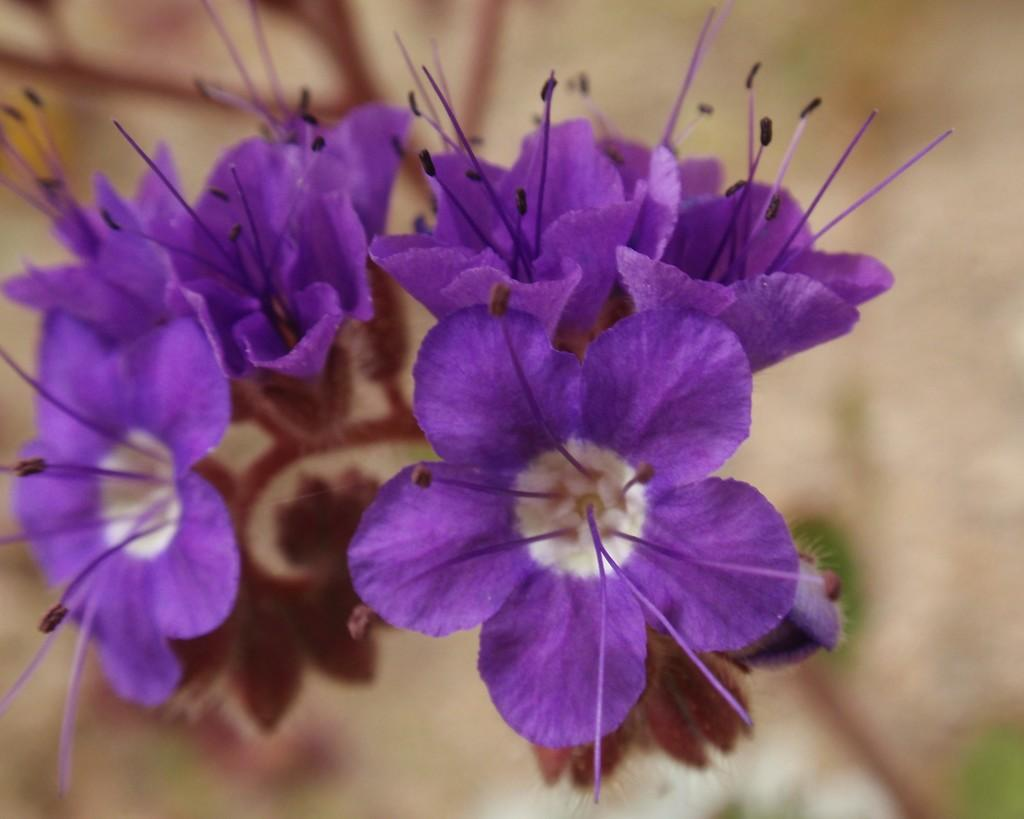What type of living organisms can be seen in the image? There are flowers in the image. Can you describe the background of the image? The background of the image is blurred. What type of education can be seen in the image? There is no reference to education in the image; it features flowers and a blurred background. What hobbies are the flowers participating in within the image? The flowers are not participating in any hobbies, as they are inanimate objects and do not have the ability to engage in activities. 